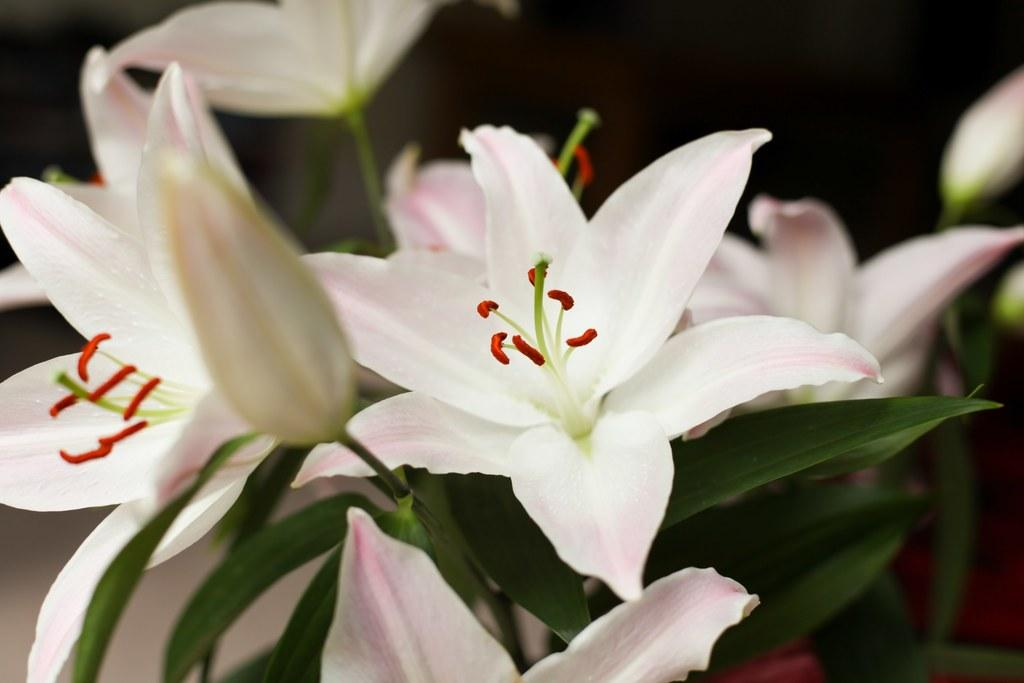What type of flowers can be seen in the foreground of the image? There are white color flowers in the foreground of the image. What else is present in the foreground of the image besides the flowers? There are leaves in the foreground of the image. How would you describe the background of the image? The background of the image is blurry. How many legs can be seen on the icicle in the image? There is no icicle present in the image, so it is not possible to determine the number of legs on it. 